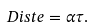<formula> <loc_0><loc_0><loc_500><loc_500>\ D i s t e = \alpha \tau .</formula> 